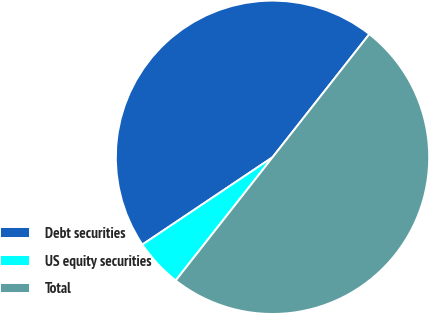<chart> <loc_0><loc_0><loc_500><loc_500><pie_chart><fcel>Debt securities<fcel>US equity securities<fcel>Total<nl><fcel>45.0%<fcel>5.0%<fcel>50.0%<nl></chart> 